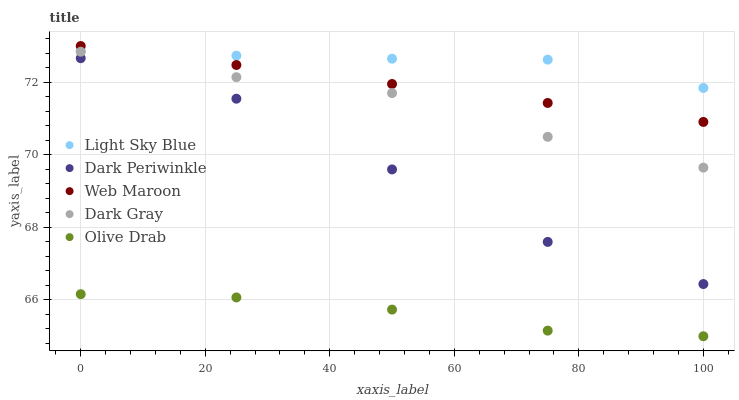Does Olive Drab have the minimum area under the curve?
Answer yes or no. Yes. Does Light Sky Blue have the maximum area under the curve?
Answer yes or no. Yes. Does Web Maroon have the minimum area under the curve?
Answer yes or no. No. Does Web Maroon have the maximum area under the curve?
Answer yes or no. No. Is Web Maroon the smoothest?
Answer yes or no. Yes. Is Dark Periwinkle the roughest?
Answer yes or no. Yes. Is Light Sky Blue the smoothest?
Answer yes or no. No. Is Light Sky Blue the roughest?
Answer yes or no. No. Does Olive Drab have the lowest value?
Answer yes or no. Yes. Does Web Maroon have the lowest value?
Answer yes or no. No. Does Web Maroon have the highest value?
Answer yes or no. Yes. Does Light Sky Blue have the highest value?
Answer yes or no. No. Is Dark Periwinkle less than Dark Gray?
Answer yes or no. Yes. Is Web Maroon greater than Dark Gray?
Answer yes or no. Yes. Does Web Maroon intersect Light Sky Blue?
Answer yes or no. Yes. Is Web Maroon less than Light Sky Blue?
Answer yes or no. No. Is Web Maroon greater than Light Sky Blue?
Answer yes or no. No. Does Dark Periwinkle intersect Dark Gray?
Answer yes or no. No. 